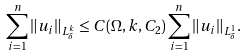<formula> <loc_0><loc_0><loc_500><loc_500>\sum _ { i = 1 } ^ { n } \| u _ { i } \| _ { L ^ { k } _ { \delta } } \leq C ( \Omega , k , C _ { 2 } ) \sum _ { i = 1 } ^ { n } \| u _ { i } \| _ { L ^ { 1 } _ { \delta } } .</formula> 